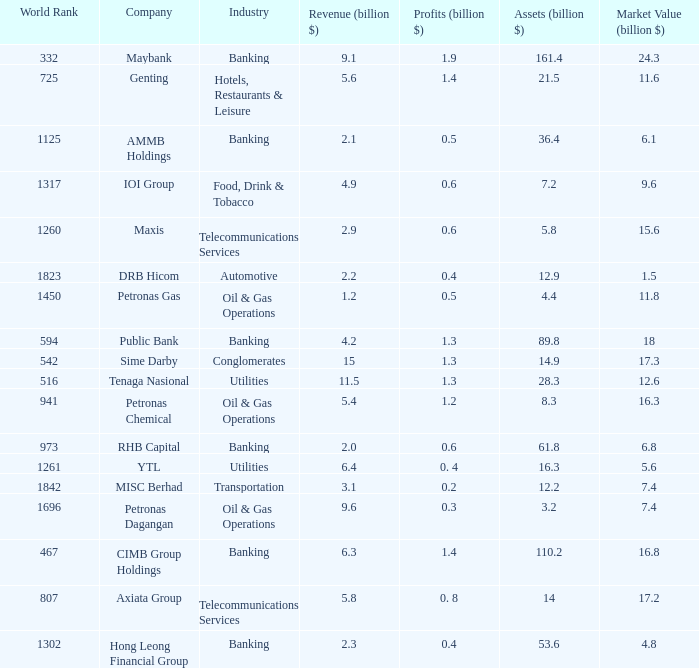Name the profits for market value of 11.8 0.5. 